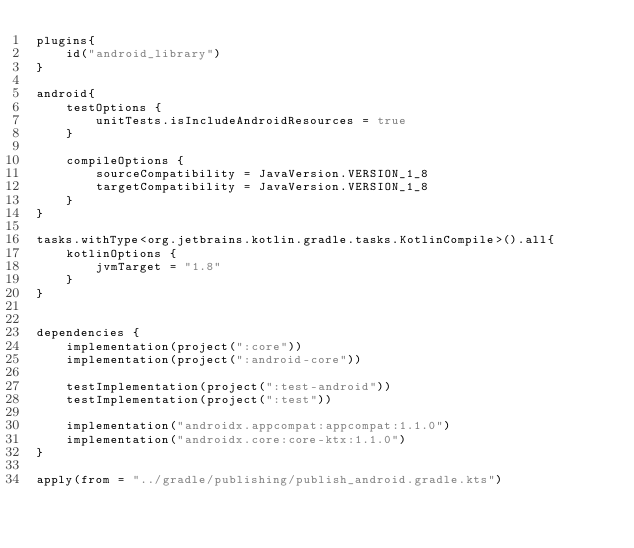<code> <loc_0><loc_0><loc_500><loc_500><_Kotlin_>plugins{
    id("android_library")
}

android{
    testOptions {
        unitTests.isIncludeAndroidResources = true
    }

    compileOptions {
        sourceCompatibility = JavaVersion.VERSION_1_8
        targetCompatibility = JavaVersion.VERSION_1_8
    }
}

tasks.withType<org.jetbrains.kotlin.gradle.tasks.KotlinCompile>().all{
    kotlinOptions {
        jvmTarget = "1.8"
    }
}


dependencies {
    implementation(project(":core"))
    implementation(project(":android-core"))

    testImplementation(project(":test-android"))
    testImplementation(project(":test"))

    implementation("androidx.appcompat:appcompat:1.1.0")
    implementation("androidx.core:core-ktx:1.1.0")
}

apply(from = "../gradle/publishing/publish_android.gradle.kts")
</code> 